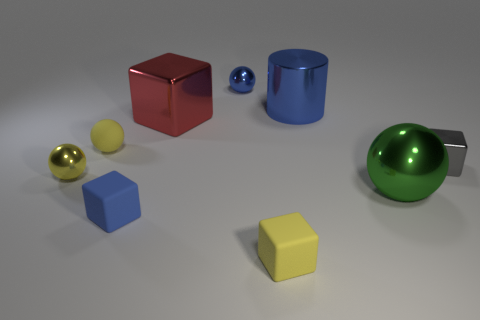Subtract all red cubes. How many cubes are left? 3 Subtract all gray blocks. How many blocks are left? 3 Subtract 0 cyan cubes. How many objects are left? 9 Subtract all balls. How many objects are left? 5 Subtract 1 cubes. How many cubes are left? 3 Subtract all brown blocks. Subtract all green cylinders. How many blocks are left? 4 Subtract all yellow cubes. How many gray balls are left? 0 Subtract all yellow metallic balls. Subtract all red blocks. How many objects are left? 7 Add 1 large blocks. How many large blocks are left? 2 Add 3 matte spheres. How many matte spheres exist? 4 